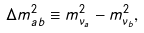Convert formula to latex. <formula><loc_0><loc_0><loc_500><loc_500>\Delta m _ { a b } ^ { 2 } \equiv m _ { \nu _ { a } } ^ { 2 } - m _ { \nu _ { b } } ^ { 2 } ,</formula> 